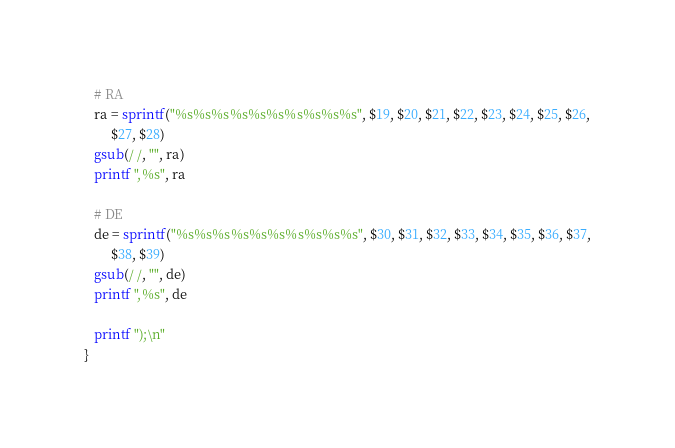Convert code to text. <code><loc_0><loc_0><loc_500><loc_500><_Awk_>
   # RA
   ra = sprintf("%s%s%s%s%s%s%s%s%s%s", $19, $20, $21, $22, $23, $24, $25, $26,
        $27, $28)
   gsub(/ /, "", ra)
   printf ",%s", ra

   # DE
   de = sprintf("%s%s%s%s%s%s%s%s%s%s", $30, $31, $32, $33, $34, $35, $36, $37,
        $38, $39)
   gsub(/ /, "", de)
   printf ",%s", de

   printf ");\n"
}
</code> 